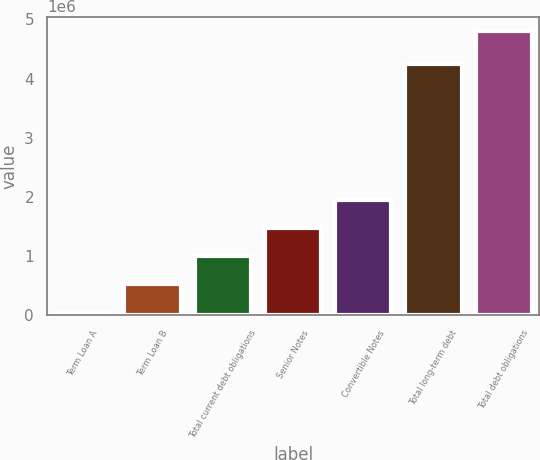<chart> <loc_0><loc_0><loc_500><loc_500><bar_chart><fcel>Term Loan A<fcel>Term Loan B<fcel>Total current debt obligations<fcel>Senior Notes<fcel>Convertible Notes<fcel>Total long-term debt<fcel>Total debt obligations<nl><fcel>49713<fcel>525333<fcel>1.00095e+06<fcel>1.47657e+06<fcel>1.95219e+06<fcel>4.2421e+06<fcel>4.80591e+06<nl></chart> 